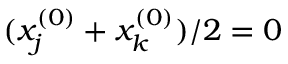Convert formula to latex. <formula><loc_0><loc_0><loc_500><loc_500>( x _ { j } ^ { ( 0 ) } + x _ { k } ^ { ( 0 ) } ) / 2 = 0</formula> 